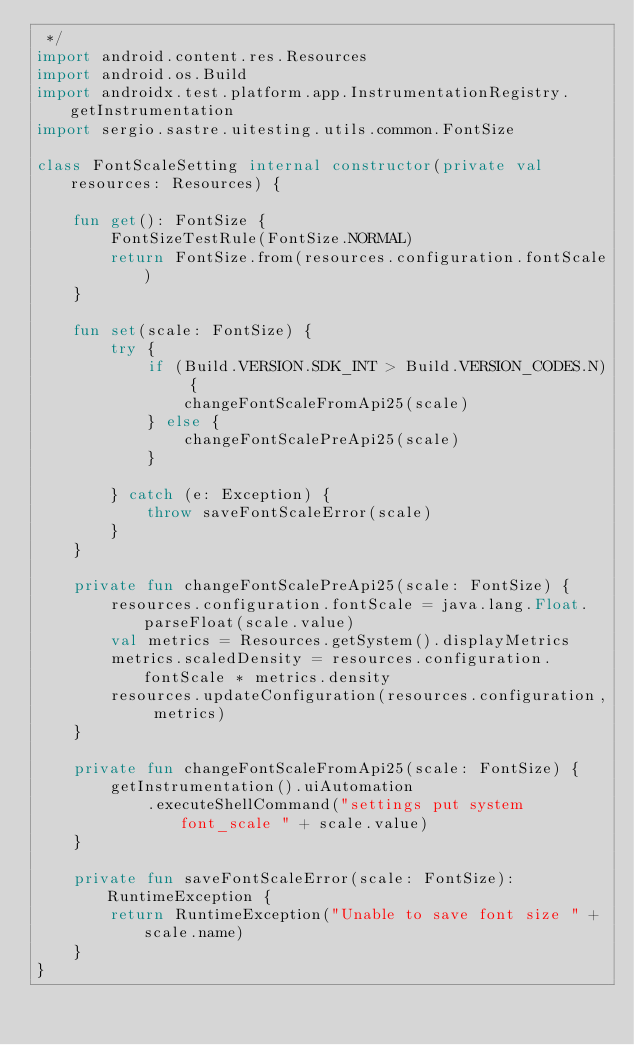Convert code to text. <code><loc_0><loc_0><loc_500><loc_500><_Kotlin_> */
import android.content.res.Resources
import android.os.Build
import androidx.test.platform.app.InstrumentationRegistry.getInstrumentation
import sergio.sastre.uitesting.utils.common.FontSize

class FontScaleSetting internal constructor(private val resources: Resources) {

    fun get(): FontSize {
        FontSizeTestRule(FontSize.NORMAL)
        return FontSize.from(resources.configuration.fontScale)
    }

    fun set(scale: FontSize) {
        try {
            if (Build.VERSION.SDK_INT > Build.VERSION_CODES.N) {
                changeFontScaleFromApi25(scale)
            } else {
                changeFontScalePreApi25(scale)
            }

        } catch (e: Exception) {
            throw saveFontScaleError(scale)
        }
    }

    private fun changeFontScalePreApi25(scale: FontSize) {
        resources.configuration.fontScale = java.lang.Float.parseFloat(scale.value)
        val metrics = Resources.getSystem().displayMetrics
        metrics.scaledDensity = resources.configuration.fontScale * metrics.density
        resources.updateConfiguration(resources.configuration, metrics)
    }

    private fun changeFontScaleFromApi25(scale: FontSize) {
        getInstrumentation().uiAutomation
            .executeShellCommand("settings put system font_scale " + scale.value)
    }

    private fun saveFontScaleError(scale: FontSize): RuntimeException {
        return RuntimeException("Unable to save font size " + scale.name)
    }
}
</code> 